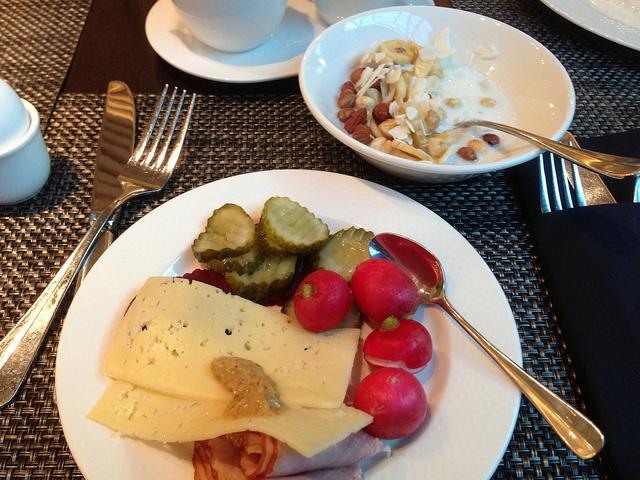What is the green stuff called on the plate? Please explain your reasoning. pickle. Sliced, green circles are on a plate with other vegetables. 